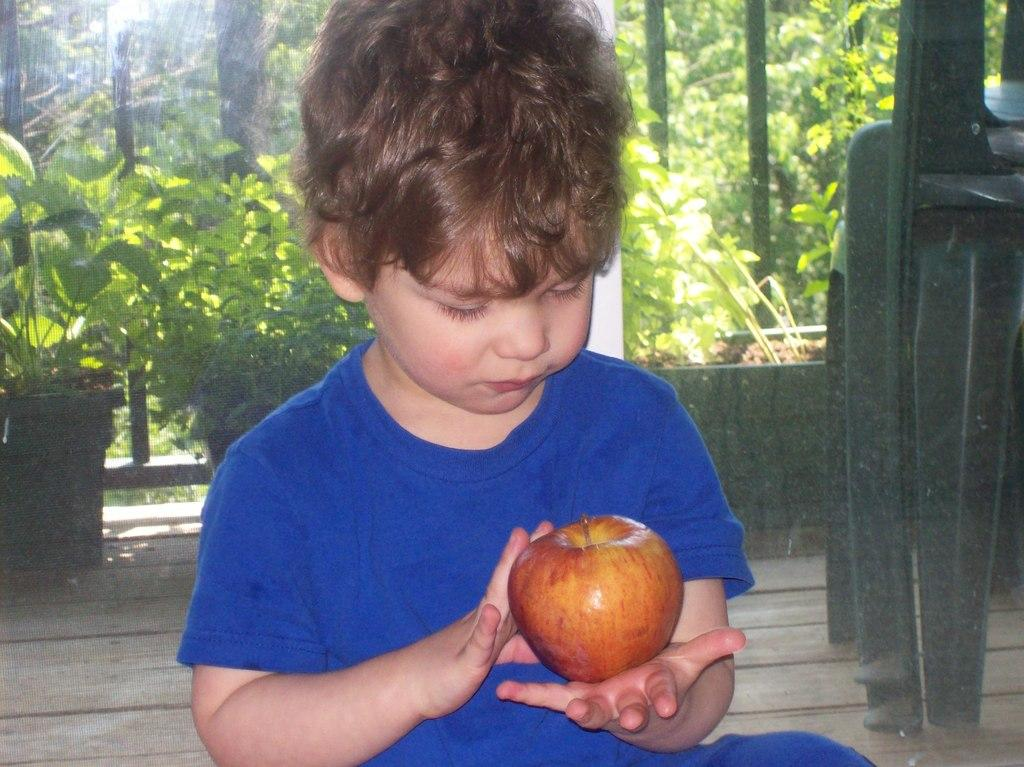Who is the main subject in the image? There is a boy in the middle of the image. What is the boy holding in the image? The boy is holding an apple. What can be seen in the background of the image? There are chairs, plants, and trees in the background of the image. What type of skate is the boy using to balance the apple in the image? There is no skate present in the image; the boy is simply holding an apple. Can you describe the boy's facial expression in the image? The provided facts do not mention the boy's facial expression, so it cannot be determined from the image. 